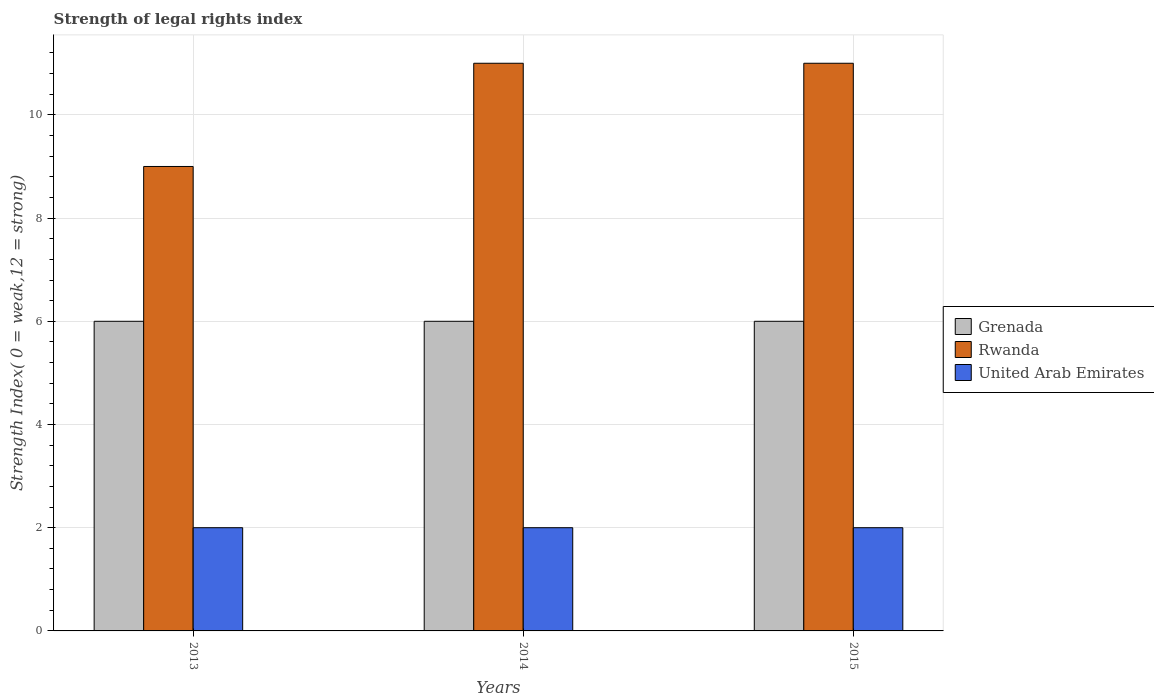How many groups of bars are there?
Offer a very short reply. 3. Are the number of bars on each tick of the X-axis equal?
Keep it short and to the point. Yes. What is the strength index in United Arab Emirates in 2015?
Provide a succinct answer. 2. Across all years, what is the maximum strength index in Rwanda?
Offer a terse response. 11. Across all years, what is the minimum strength index in United Arab Emirates?
Your answer should be compact. 2. In which year was the strength index in Grenada minimum?
Offer a terse response. 2013. What is the total strength index in Grenada in the graph?
Your answer should be compact. 18. What is the difference between the strength index in Grenada in 2014 and the strength index in Rwanda in 2013?
Make the answer very short. -3. What is the average strength index in Grenada per year?
Make the answer very short. 6. In the year 2015, what is the difference between the strength index in United Arab Emirates and strength index in Rwanda?
Provide a short and direct response. -9. In how many years, is the strength index in United Arab Emirates greater than 10.4?
Ensure brevity in your answer.  0. What is the ratio of the strength index in Rwanda in 2013 to that in 2015?
Your answer should be very brief. 0.82. Is the strength index in Rwanda in 2013 less than that in 2015?
Ensure brevity in your answer.  Yes. Is the difference between the strength index in United Arab Emirates in 2013 and 2015 greater than the difference between the strength index in Rwanda in 2013 and 2015?
Your response must be concise. Yes. In how many years, is the strength index in Grenada greater than the average strength index in Grenada taken over all years?
Keep it short and to the point. 0. What does the 3rd bar from the left in 2014 represents?
Your response must be concise. United Arab Emirates. What does the 1st bar from the right in 2013 represents?
Provide a succinct answer. United Arab Emirates. Is it the case that in every year, the sum of the strength index in Grenada and strength index in United Arab Emirates is greater than the strength index in Rwanda?
Make the answer very short. No. How many years are there in the graph?
Keep it short and to the point. 3. What is the difference between two consecutive major ticks on the Y-axis?
Your response must be concise. 2. Does the graph contain any zero values?
Offer a very short reply. No. How many legend labels are there?
Ensure brevity in your answer.  3. What is the title of the graph?
Provide a short and direct response. Strength of legal rights index. Does "Niger" appear as one of the legend labels in the graph?
Provide a short and direct response. No. What is the label or title of the Y-axis?
Offer a terse response. Strength Index( 0 = weak,12 = strong). What is the Strength Index( 0 = weak,12 = strong) of United Arab Emirates in 2013?
Your response must be concise. 2. What is the Strength Index( 0 = weak,12 = strong) in Rwanda in 2014?
Your answer should be compact. 11. What is the Strength Index( 0 = weak,12 = strong) in Grenada in 2015?
Give a very brief answer. 6. What is the Strength Index( 0 = weak,12 = strong) in United Arab Emirates in 2015?
Your answer should be very brief. 2. What is the total Strength Index( 0 = weak,12 = strong) of Grenada in the graph?
Offer a very short reply. 18. What is the difference between the Strength Index( 0 = weak,12 = strong) of Rwanda in 2013 and that in 2014?
Give a very brief answer. -2. What is the difference between the Strength Index( 0 = weak,12 = strong) of United Arab Emirates in 2013 and that in 2014?
Provide a short and direct response. 0. What is the difference between the Strength Index( 0 = weak,12 = strong) in Rwanda in 2013 and that in 2015?
Offer a terse response. -2. What is the difference between the Strength Index( 0 = weak,12 = strong) in United Arab Emirates in 2013 and that in 2015?
Provide a succinct answer. 0. What is the difference between the Strength Index( 0 = weak,12 = strong) in Rwanda in 2014 and that in 2015?
Give a very brief answer. 0. What is the difference between the Strength Index( 0 = weak,12 = strong) in Rwanda in 2013 and the Strength Index( 0 = weak,12 = strong) in United Arab Emirates in 2014?
Offer a very short reply. 7. What is the difference between the Strength Index( 0 = weak,12 = strong) in Grenada in 2013 and the Strength Index( 0 = weak,12 = strong) in Rwanda in 2015?
Provide a succinct answer. -5. What is the difference between the Strength Index( 0 = weak,12 = strong) of Rwanda in 2013 and the Strength Index( 0 = weak,12 = strong) of United Arab Emirates in 2015?
Make the answer very short. 7. What is the difference between the Strength Index( 0 = weak,12 = strong) in Grenada in 2014 and the Strength Index( 0 = weak,12 = strong) in Rwanda in 2015?
Keep it short and to the point. -5. What is the difference between the Strength Index( 0 = weak,12 = strong) of Rwanda in 2014 and the Strength Index( 0 = weak,12 = strong) of United Arab Emirates in 2015?
Provide a succinct answer. 9. What is the average Strength Index( 0 = weak,12 = strong) of Grenada per year?
Provide a succinct answer. 6. What is the average Strength Index( 0 = weak,12 = strong) of Rwanda per year?
Offer a terse response. 10.33. In the year 2013, what is the difference between the Strength Index( 0 = weak,12 = strong) in Grenada and Strength Index( 0 = weak,12 = strong) in United Arab Emirates?
Provide a succinct answer. 4. In the year 2013, what is the difference between the Strength Index( 0 = weak,12 = strong) of Rwanda and Strength Index( 0 = weak,12 = strong) of United Arab Emirates?
Provide a succinct answer. 7. In the year 2014, what is the difference between the Strength Index( 0 = weak,12 = strong) of Grenada and Strength Index( 0 = weak,12 = strong) of Rwanda?
Provide a short and direct response. -5. In the year 2014, what is the difference between the Strength Index( 0 = weak,12 = strong) of Grenada and Strength Index( 0 = weak,12 = strong) of United Arab Emirates?
Give a very brief answer. 4. In the year 2015, what is the difference between the Strength Index( 0 = weak,12 = strong) of Grenada and Strength Index( 0 = weak,12 = strong) of United Arab Emirates?
Offer a terse response. 4. In the year 2015, what is the difference between the Strength Index( 0 = weak,12 = strong) in Rwanda and Strength Index( 0 = weak,12 = strong) in United Arab Emirates?
Make the answer very short. 9. What is the ratio of the Strength Index( 0 = weak,12 = strong) of Grenada in 2013 to that in 2014?
Provide a succinct answer. 1. What is the ratio of the Strength Index( 0 = weak,12 = strong) in Rwanda in 2013 to that in 2014?
Your answer should be very brief. 0.82. What is the ratio of the Strength Index( 0 = weak,12 = strong) of Grenada in 2013 to that in 2015?
Your answer should be compact. 1. What is the ratio of the Strength Index( 0 = weak,12 = strong) in Rwanda in 2013 to that in 2015?
Offer a terse response. 0.82. What is the ratio of the Strength Index( 0 = weak,12 = strong) of United Arab Emirates in 2013 to that in 2015?
Your response must be concise. 1. What is the ratio of the Strength Index( 0 = weak,12 = strong) in Grenada in 2014 to that in 2015?
Make the answer very short. 1. What is the ratio of the Strength Index( 0 = weak,12 = strong) of Rwanda in 2014 to that in 2015?
Offer a very short reply. 1. What is the ratio of the Strength Index( 0 = weak,12 = strong) in United Arab Emirates in 2014 to that in 2015?
Provide a succinct answer. 1. What is the difference between the highest and the second highest Strength Index( 0 = weak,12 = strong) of Grenada?
Ensure brevity in your answer.  0. What is the difference between the highest and the second highest Strength Index( 0 = weak,12 = strong) of Rwanda?
Your response must be concise. 0. What is the difference between the highest and the second highest Strength Index( 0 = weak,12 = strong) in United Arab Emirates?
Provide a succinct answer. 0. What is the difference between the highest and the lowest Strength Index( 0 = weak,12 = strong) in United Arab Emirates?
Offer a terse response. 0. 